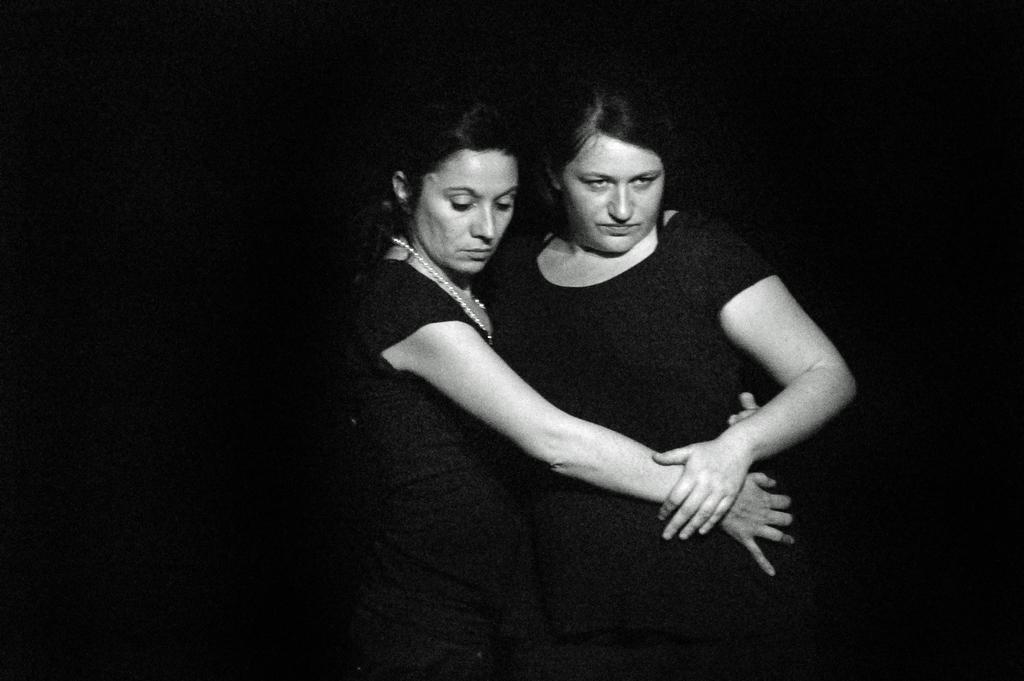How many women are in the image? There are women in the image. What are the women doing in the image? The women are standing and holding each other. What type of sofa can be seen in the image? There is no sofa present in the image. What shape do the women form while holding each other? The women's positions and the image's perspective do not allow us to determine a specific shape they might form. 